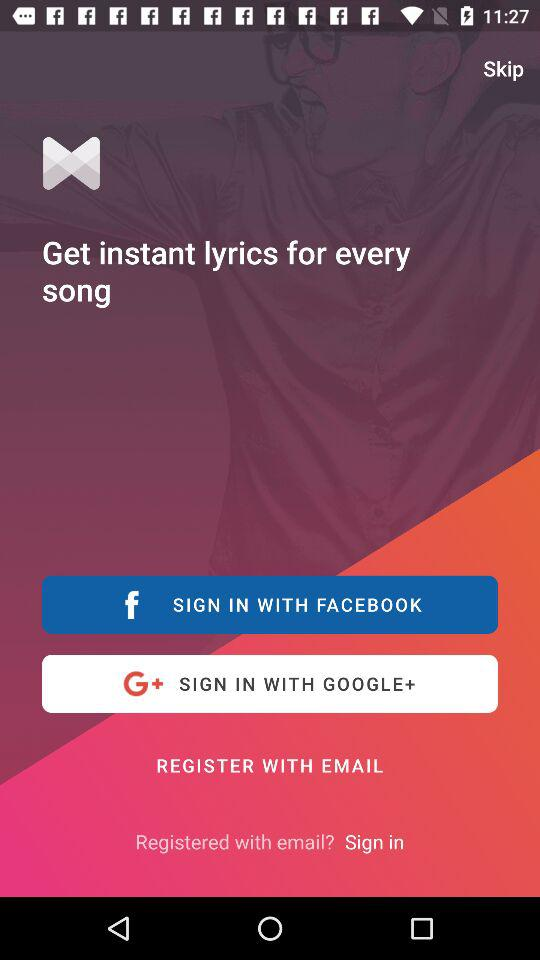What can I get instantly for every song? You can get instant lyrics for every song. 